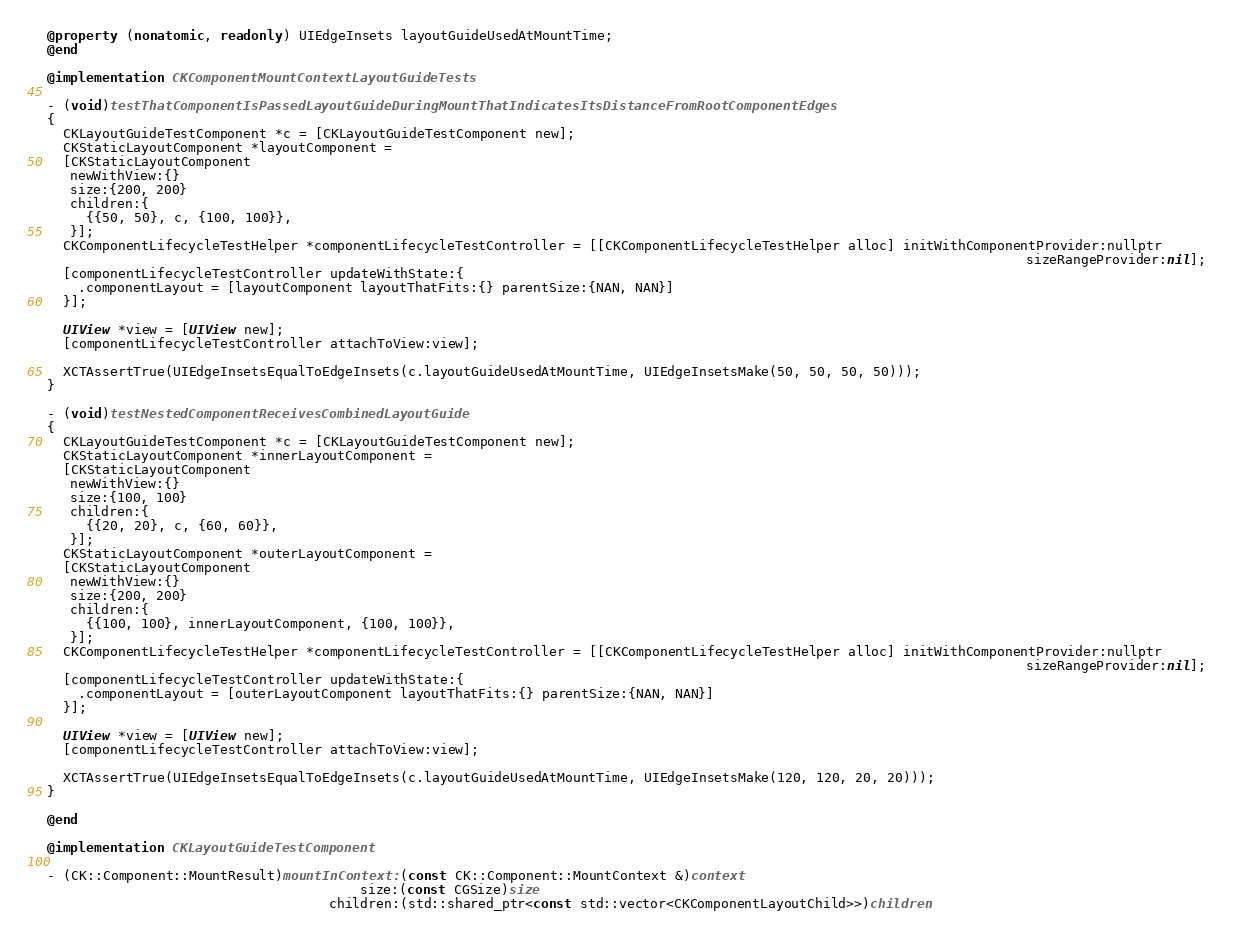Convert code to text. <code><loc_0><loc_0><loc_500><loc_500><_ObjectiveC_>@property (nonatomic, readonly) UIEdgeInsets layoutGuideUsedAtMountTime;
@end

@implementation CKComponentMountContextLayoutGuideTests

- (void)testThatComponentIsPassedLayoutGuideDuringMountThatIndicatesItsDistanceFromRootComponentEdges
{
  CKLayoutGuideTestComponent *c = [CKLayoutGuideTestComponent new];
  CKStaticLayoutComponent *layoutComponent =
  [CKStaticLayoutComponent
   newWithView:{}
   size:{200, 200}
   children:{
     {{50, 50}, c, {100, 100}},
   }];
  CKComponentLifecycleTestHelper *componentLifecycleTestController = [[CKComponentLifecycleTestHelper alloc] initWithComponentProvider:nullptr
                                                                                                                             sizeRangeProvider:nil];
  [componentLifecycleTestController updateWithState:{
    .componentLayout = [layoutComponent layoutThatFits:{} parentSize:{NAN, NAN}]
  }];

  UIView *view = [UIView new];
  [componentLifecycleTestController attachToView:view];

  XCTAssertTrue(UIEdgeInsetsEqualToEdgeInsets(c.layoutGuideUsedAtMountTime, UIEdgeInsetsMake(50, 50, 50, 50)));
}

- (void)testNestedComponentReceivesCombinedLayoutGuide
{
  CKLayoutGuideTestComponent *c = [CKLayoutGuideTestComponent new];
  CKStaticLayoutComponent *innerLayoutComponent =
  [CKStaticLayoutComponent
   newWithView:{}
   size:{100, 100}
   children:{
     {{20, 20}, c, {60, 60}},
   }];
  CKStaticLayoutComponent *outerLayoutComponent =
  [CKStaticLayoutComponent
   newWithView:{}
   size:{200, 200}
   children:{
     {{100, 100}, innerLayoutComponent, {100, 100}},
   }];
  CKComponentLifecycleTestHelper *componentLifecycleTestController = [[CKComponentLifecycleTestHelper alloc] initWithComponentProvider:nullptr
                                                                                                                             sizeRangeProvider:nil];
  [componentLifecycleTestController updateWithState:{
    .componentLayout = [outerLayoutComponent layoutThatFits:{} parentSize:{NAN, NAN}]
  }];

  UIView *view = [UIView new];
  [componentLifecycleTestController attachToView:view];

  XCTAssertTrue(UIEdgeInsetsEqualToEdgeInsets(c.layoutGuideUsedAtMountTime, UIEdgeInsetsMake(120, 120, 20, 20)));
}

@end

@implementation CKLayoutGuideTestComponent

- (CK::Component::MountResult)mountInContext:(const CK::Component::MountContext &)context
                                        size:(const CGSize)size
                                    children:(std::shared_ptr<const std::vector<CKComponentLayoutChild>>)children</code> 